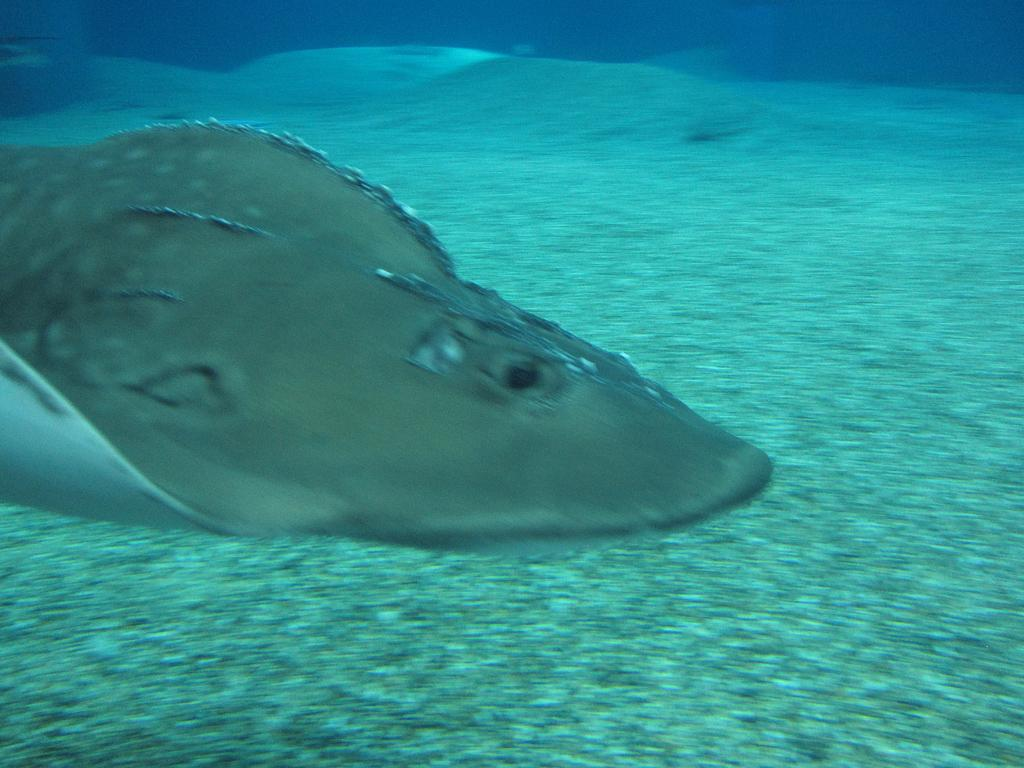What type of environment is depicted in the image? The image shows a scene in the sea. Can you describe the main subject in the image? There is an animal in the sea in the image. Are there any fairies flying around the animal in the image? There is no mention of fairies in the image, as it only depicts a scene in the sea with an animal. 